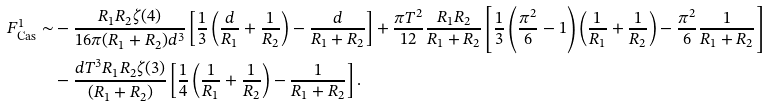Convert formula to latex. <formula><loc_0><loc_0><loc_500><loc_500>F _ { \text {Cas} } ^ { 1 } \sim & - \frac { R _ { 1 } R _ { 2 } \zeta ( 4 ) } { 1 6 \pi ( R _ { 1 } + R _ { 2 } ) d ^ { 3 } } \left [ \frac { 1 } { 3 } \left ( \frac { d } { R _ { 1 } } + \frac { 1 } { R _ { 2 } } \right ) - \frac { d } { R _ { 1 } + R _ { 2 } } \right ] + \frac { \pi T ^ { 2 } } { 1 2 } \frac { R _ { 1 } R _ { 2 } } { R _ { 1 } + R _ { 2 } } \left [ \frac { 1 } { 3 } \left ( \frac { \pi ^ { 2 } } { 6 } - 1 \right ) \left ( \frac { 1 } { R _ { 1 } } + \frac { 1 } { R _ { 2 } } \right ) - \frac { \pi ^ { 2 } } { 6 } \frac { 1 } { R _ { 1 } + R _ { 2 } } \right ] \\ & - \frac { d T ^ { 3 } R _ { 1 } R _ { 2 } \zeta ( 3 ) } { ( R _ { 1 } + R _ { 2 } ) } \left [ \frac { 1 } { 4 } \left ( \frac { 1 } { R _ { 1 } } + \frac { 1 } { R _ { 2 } } \right ) - \frac { 1 } { R _ { 1 } + R _ { 2 } } \right ] .</formula> 